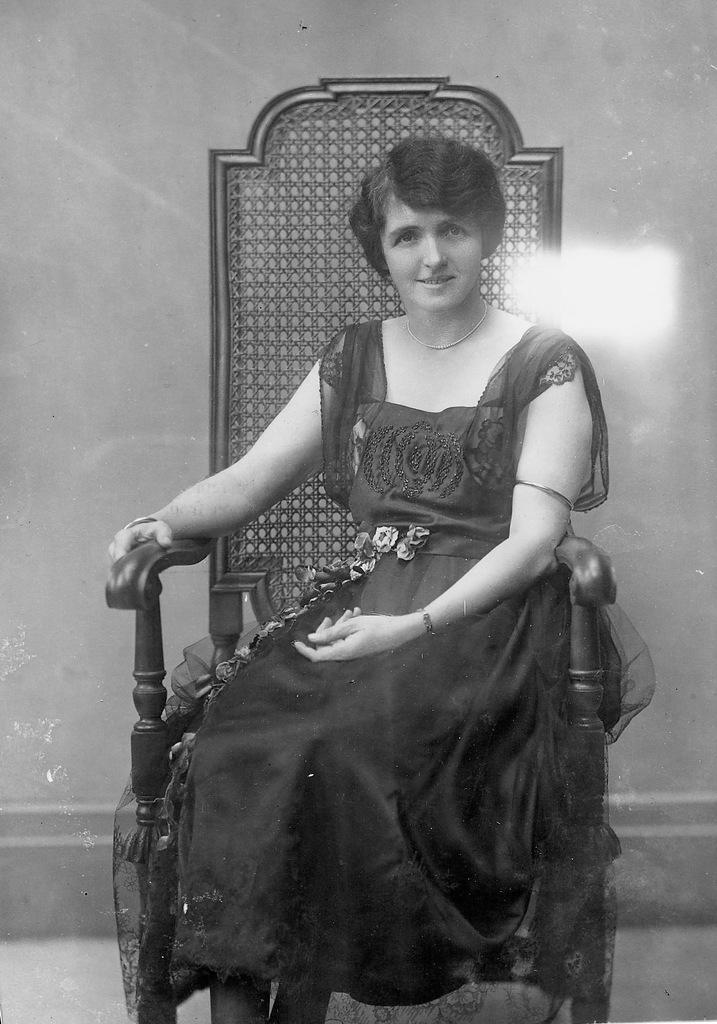What type of image is this? The image is a black and white photograph. Who is in the image? There is a woman in the image. What is the woman wearing? The woman is wearing a gown. What is the woman doing in the image? The woman is sitting on a chair. What can be seen in the background of the image? There is a wall in the background of the image. What is the woman discussing with her grandfather in the image? There is no grandfather present in the image, and the woman is not engaged in any discussion. 